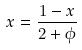<formula> <loc_0><loc_0><loc_500><loc_500>x = \frac { 1 - x } { 2 + \phi }</formula> 